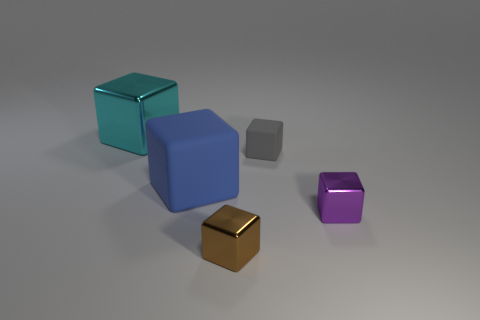Are there any tiny gray objects behind the object behind the matte cube that is behind the blue cube? no 